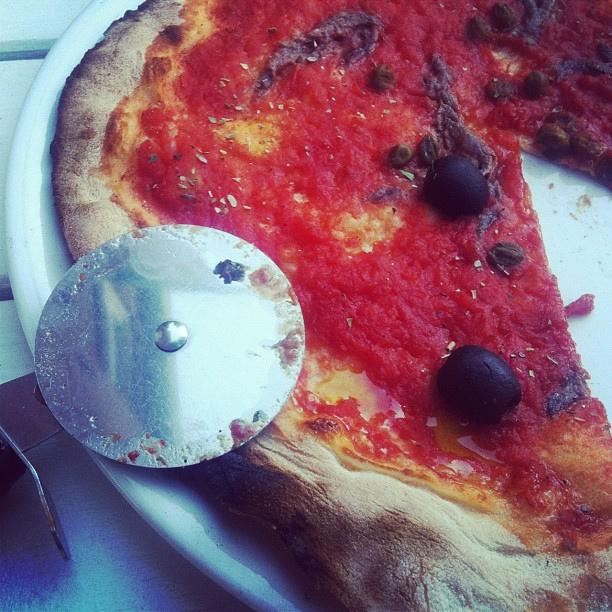Are there any pieces missing from the pizza?
Write a very short answer. Yes. Is the slicer dirty?
Concise answer only. Yes. Are the olives on the pizza sliced?
Short answer required. No. 